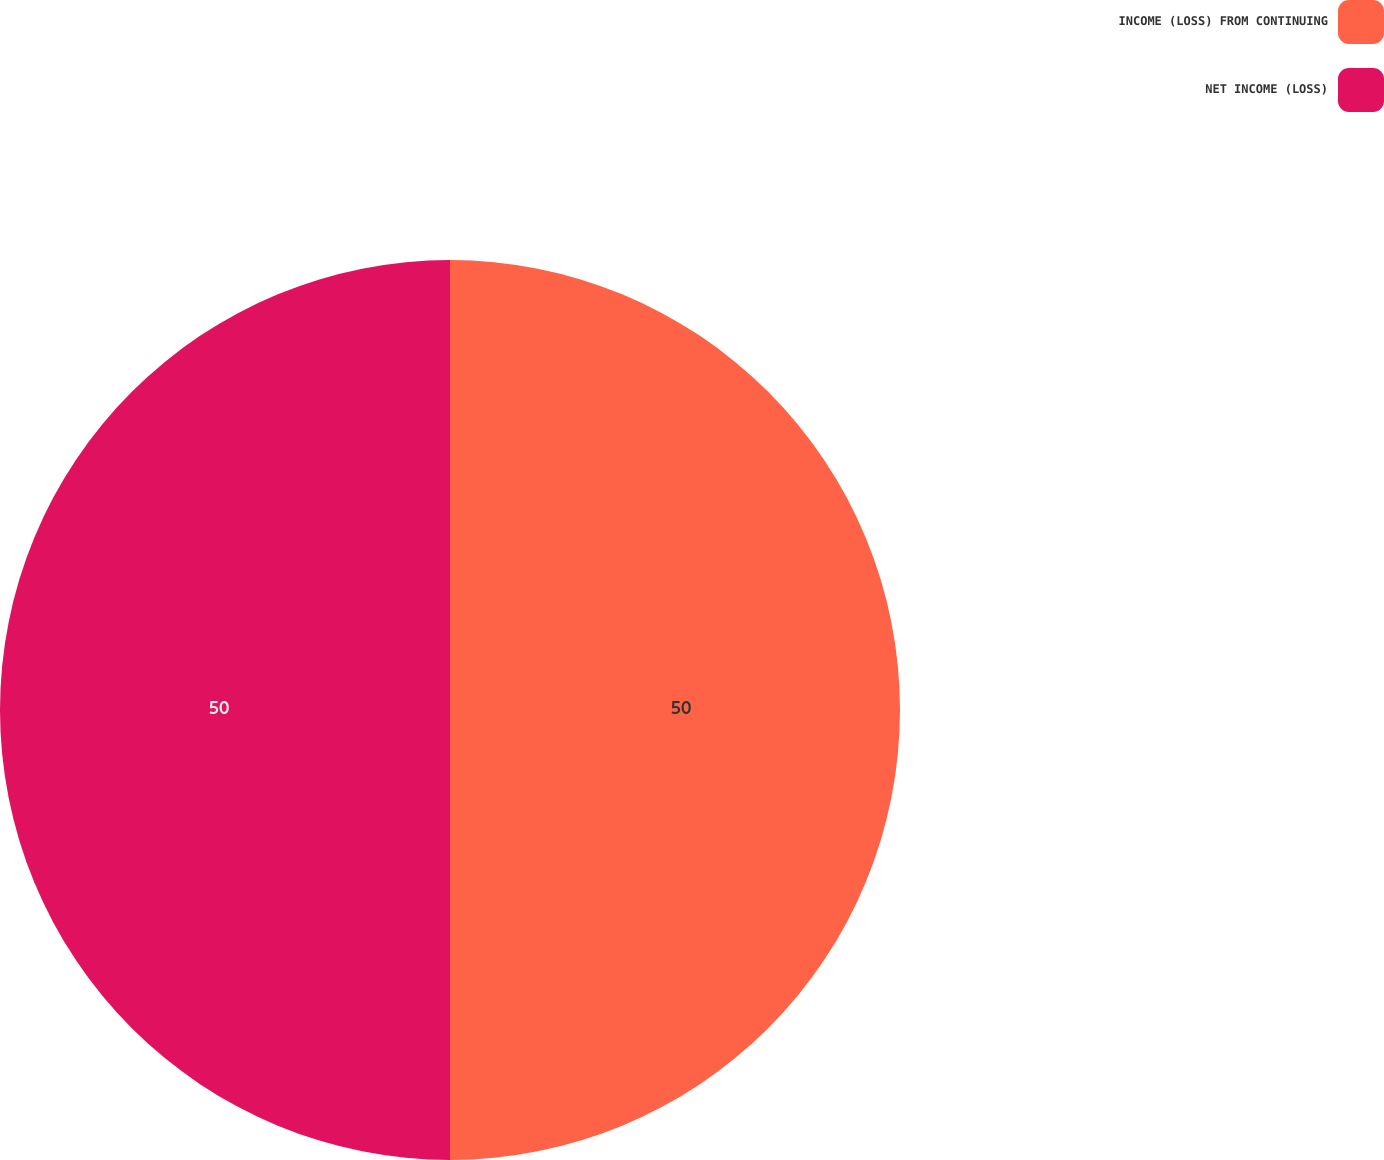<chart> <loc_0><loc_0><loc_500><loc_500><pie_chart><fcel>INCOME (LOSS) FROM CONTINUING<fcel>NET INCOME (LOSS)<nl><fcel>50.0%<fcel>50.0%<nl></chart> 